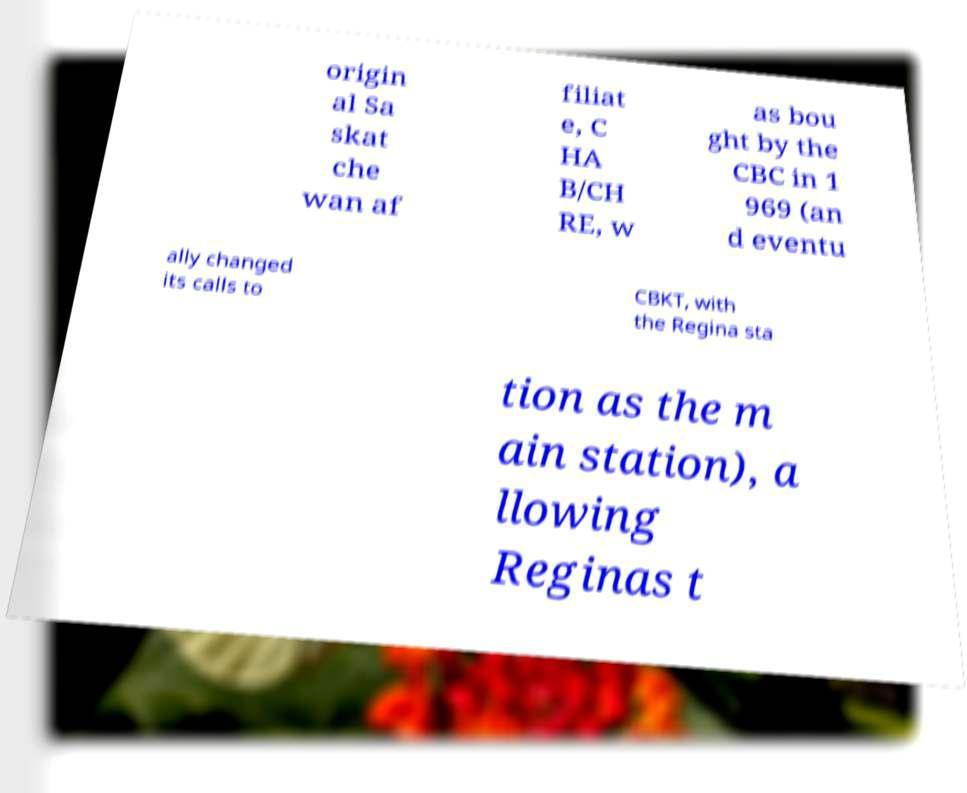There's text embedded in this image that I need extracted. Can you transcribe it verbatim? origin al Sa skat che wan af filiat e, C HA B/CH RE, w as bou ght by the CBC in 1 969 (an d eventu ally changed its calls to CBKT, with the Regina sta tion as the m ain station), a llowing Reginas t 